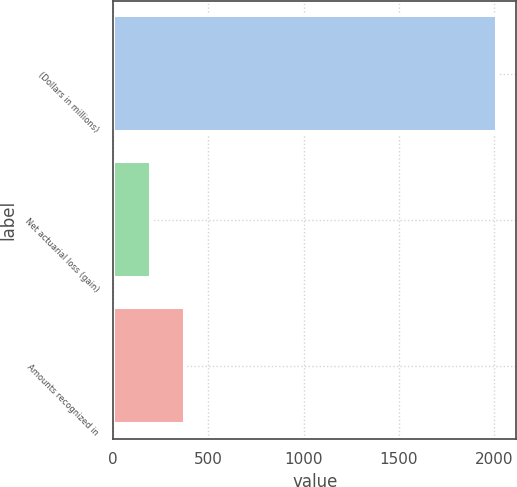<chart> <loc_0><loc_0><loc_500><loc_500><bar_chart><fcel>(Dollars in millions)<fcel>Net actuarial loss (gain)<fcel>Amounts recognized in<nl><fcel>2017<fcel>196<fcel>378.1<nl></chart> 